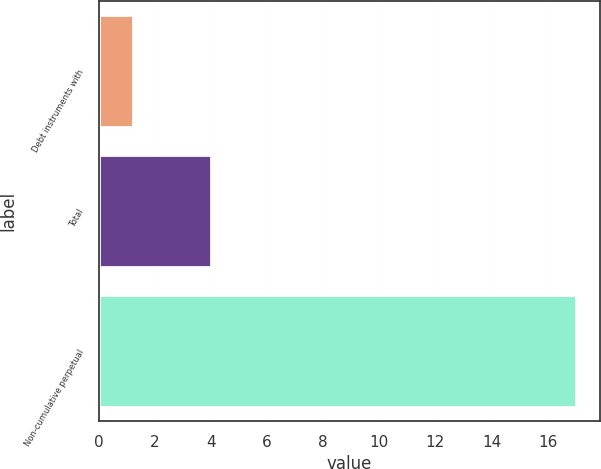Convert chart. <chart><loc_0><loc_0><loc_500><loc_500><bar_chart><fcel>Debt instruments with<fcel>Total<fcel>Non-cumulative perpetual<nl><fcel>1.2<fcel>4<fcel>17<nl></chart> 